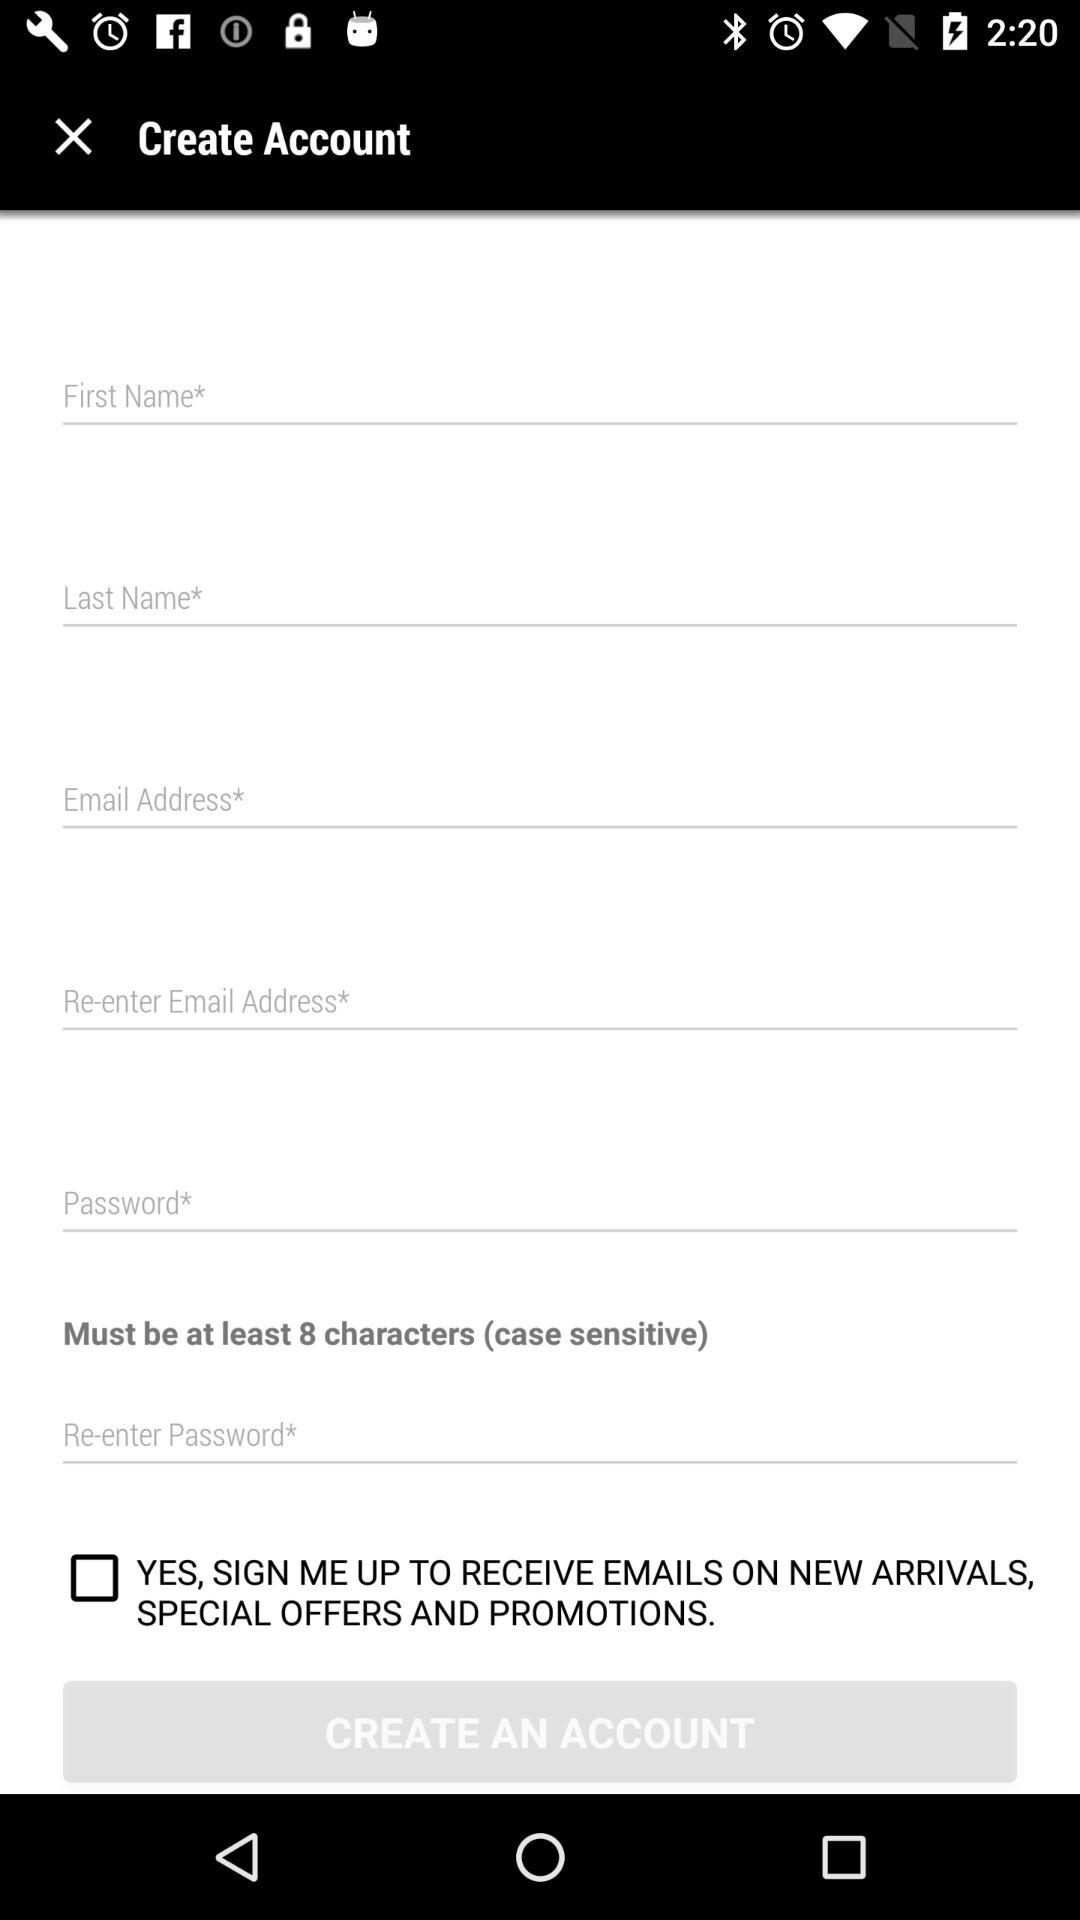How many characters at a minimum are required to make a password? The minimum number of characters required to make a password is 8. 